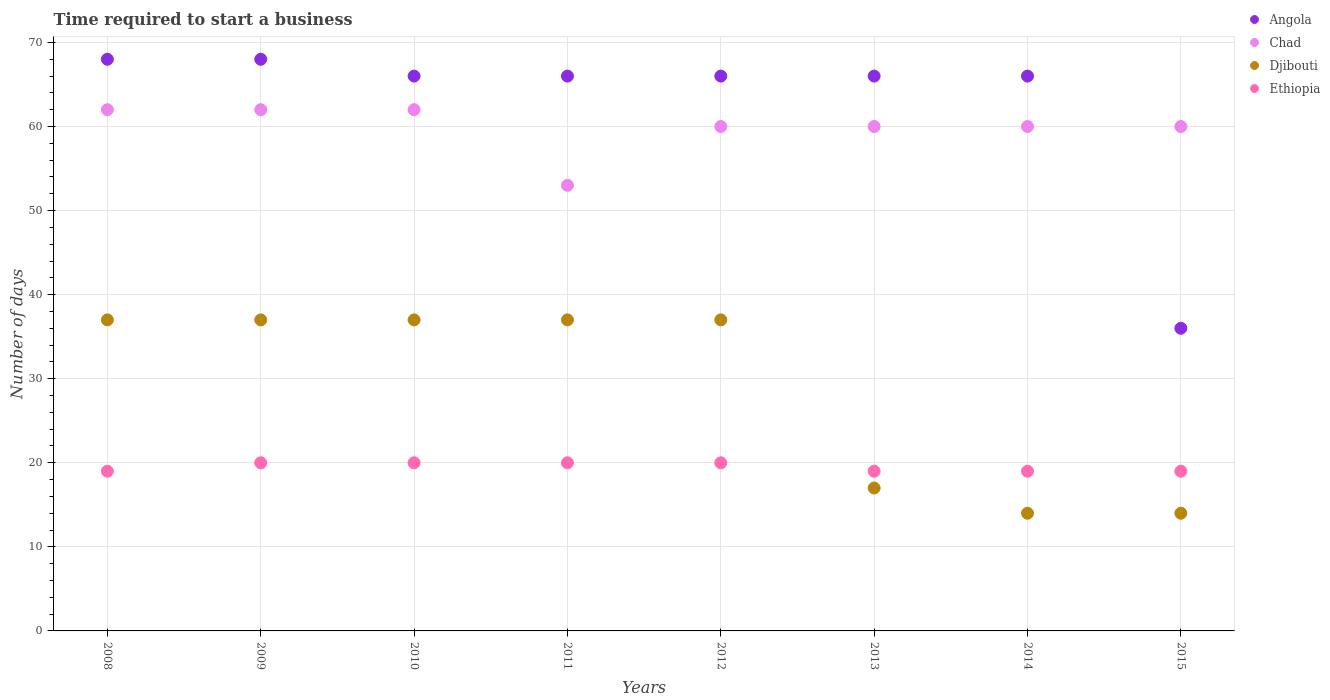Is the number of dotlines equal to the number of legend labels?
Provide a succinct answer. Yes. Across all years, what is the maximum number of days required to start a business in Angola?
Your answer should be very brief. 68. Across all years, what is the minimum number of days required to start a business in Chad?
Offer a very short reply. 53. What is the total number of days required to start a business in Chad in the graph?
Provide a short and direct response. 479. What is the difference between the number of days required to start a business in Chad in 2011 and that in 2015?
Keep it short and to the point. -7. What is the difference between the number of days required to start a business in Ethiopia in 2013 and the number of days required to start a business in Djibouti in 2010?
Ensure brevity in your answer.  -18. What is the average number of days required to start a business in Chad per year?
Keep it short and to the point. 59.88. In the year 2014, what is the difference between the number of days required to start a business in Chad and number of days required to start a business in Ethiopia?
Make the answer very short. 41. In how many years, is the number of days required to start a business in Angola greater than 58 days?
Provide a short and direct response. 7. Is the difference between the number of days required to start a business in Chad in 2009 and 2012 greater than the difference between the number of days required to start a business in Ethiopia in 2009 and 2012?
Your answer should be very brief. Yes. What is the difference between the highest and the lowest number of days required to start a business in Djibouti?
Provide a succinct answer. 23. Is the sum of the number of days required to start a business in Djibouti in 2010 and 2013 greater than the maximum number of days required to start a business in Angola across all years?
Give a very brief answer. No. Is it the case that in every year, the sum of the number of days required to start a business in Angola and number of days required to start a business in Djibouti  is greater than the sum of number of days required to start a business in Chad and number of days required to start a business in Ethiopia?
Make the answer very short. Yes. Is the number of days required to start a business in Ethiopia strictly greater than the number of days required to start a business in Chad over the years?
Ensure brevity in your answer.  No. Is the number of days required to start a business in Ethiopia strictly less than the number of days required to start a business in Angola over the years?
Your response must be concise. Yes. Does the graph contain any zero values?
Ensure brevity in your answer.  No. How many legend labels are there?
Your response must be concise. 4. What is the title of the graph?
Ensure brevity in your answer.  Time required to start a business. Does "South Africa" appear as one of the legend labels in the graph?
Make the answer very short. No. What is the label or title of the X-axis?
Your answer should be very brief. Years. What is the label or title of the Y-axis?
Provide a succinct answer. Number of days. What is the Number of days in Chad in 2008?
Provide a succinct answer. 62. What is the Number of days in Djibouti in 2008?
Your response must be concise. 37. What is the Number of days of Angola in 2009?
Make the answer very short. 68. What is the Number of days of Chad in 2009?
Give a very brief answer. 62. What is the Number of days of Djibouti in 2009?
Your answer should be compact. 37. What is the Number of days of Ethiopia in 2009?
Your answer should be very brief. 20. What is the Number of days of Angola in 2010?
Your answer should be compact. 66. What is the Number of days in Djibouti in 2010?
Offer a very short reply. 37. What is the Number of days in Ethiopia in 2010?
Ensure brevity in your answer.  20. What is the Number of days in Angola in 2011?
Your answer should be compact. 66. What is the Number of days in Chad in 2011?
Keep it short and to the point. 53. What is the Number of days of Djibouti in 2011?
Offer a terse response. 37. What is the Number of days of Angola in 2012?
Provide a short and direct response. 66. What is the Number of days in Chad in 2012?
Make the answer very short. 60. What is the Number of days in Djibouti in 2012?
Provide a short and direct response. 37. What is the Number of days in Ethiopia in 2012?
Your answer should be very brief. 20. What is the Number of days in Angola in 2013?
Ensure brevity in your answer.  66. What is the Number of days in Chad in 2013?
Provide a short and direct response. 60. What is the Number of days in Djibouti in 2013?
Your response must be concise. 17. What is the Number of days of Ethiopia in 2013?
Keep it short and to the point. 19. What is the Number of days in Djibouti in 2014?
Give a very brief answer. 14. What is the Number of days of Chad in 2015?
Give a very brief answer. 60. What is the Number of days of Djibouti in 2015?
Your answer should be very brief. 14. Across all years, what is the maximum Number of days of Chad?
Your answer should be very brief. 62. Across all years, what is the maximum Number of days in Ethiopia?
Provide a short and direct response. 20. Across all years, what is the minimum Number of days of Angola?
Your answer should be compact. 36. What is the total Number of days in Angola in the graph?
Your answer should be compact. 502. What is the total Number of days of Chad in the graph?
Keep it short and to the point. 479. What is the total Number of days of Djibouti in the graph?
Your answer should be very brief. 230. What is the total Number of days of Ethiopia in the graph?
Ensure brevity in your answer.  156. What is the difference between the Number of days of Angola in 2008 and that in 2010?
Your answer should be very brief. 2. What is the difference between the Number of days in Chad in 2008 and that in 2010?
Provide a short and direct response. 0. What is the difference between the Number of days of Ethiopia in 2008 and that in 2010?
Keep it short and to the point. -1. What is the difference between the Number of days in Angola in 2008 and that in 2011?
Keep it short and to the point. 2. What is the difference between the Number of days in Angola in 2008 and that in 2012?
Your response must be concise. 2. What is the difference between the Number of days in Djibouti in 2008 and that in 2012?
Offer a terse response. 0. What is the difference between the Number of days of Ethiopia in 2008 and that in 2012?
Provide a short and direct response. -1. What is the difference between the Number of days in Angola in 2008 and that in 2013?
Make the answer very short. 2. What is the difference between the Number of days of Chad in 2008 and that in 2013?
Your answer should be compact. 2. What is the difference between the Number of days in Ethiopia in 2008 and that in 2013?
Make the answer very short. 0. What is the difference between the Number of days of Ethiopia in 2008 and that in 2015?
Provide a succinct answer. 0. What is the difference between the Number of days in Angola in 2009 and that in 2010?
Ensure brevity in your answer.  2. What is the difference between the Number of days in Djibouti in 2009 and that in 2010?
Your response must be concise. 0. What is the difference between the Number of days in Angola in 2009 and that in 2011?
Keep it short and to the point. 2. What is the difference between the Number of days of Chad in 2009 and that in 2011?
Keep it short and to the point. 9. What is the difference between the Number of days of Djibouti in 2009 and that in 2011?
Keep it short and to the point. 0. What is the difference between the Number of days of Angola in 2009 and that in 2012?
Provide a short and direct response. 2. What is the difference between the Number of days in Ethiopia in 2009 and that in 2012?
Ensure brevity in your answer.  0. What is the difference between the Number of days in Angola in 2009 and that in 2013?
Your answer should be compact. 2. What is the difference between the Number of days in Djibouti in 2009 and that in 2013?
Ensure brevity in your answer.  20. What is the difference between the Number of days of Ethiopia in 2009 and that in 2013?
Your answer should be very brief. 1. What is the difference between the Number of days in Angola in 2009 and that in 2014?
Offer a very short reply. 2. What is the difference between the Number of days of Chad in 2009 and that in 2014?
Provide a succinct answer. 2. What is the difference between the Number of days of Djibouti in 2009 and that in 2014?
Ensure brevity in your answer.  23. What is the difference between the Number of days in Angola in 2009 and that in 2015?
Your answer should be compact. 32. What is the difference between the Number of days of Chad in 2009 and that in 2015?
Keep it short and to the point. 2. What is the difference between the Number of days in Ethiopia in 2009 and that in 2015?
Your answer should be compact. 1. What is the difference between the Number of days of Ethiopia in 2010 and that in 2011?
Offer a very short reply. 0. What is the difference between the Number of days in Djibouti in 2010 and that in 2013?
Give a very brief answer. 20. What is the difference between the Number of days in Ethiopia in 2010 and that in 2013?
Ensure brevity in your answer.  1. What is the difference between the Number of days in Chad in 2010 and that in 2014?
Keep it short and to the point. 2. What is the difference between the Number of days in Djibouti in 2010 and that in 2014?
Offer a terse response. 23. What is the difference between the Number of days in Angola in 2010 and that in 2015?
Make the answer very short. 30. What is the difference between the Number of days of Chad in 2010 and that in 2015?
Your answer should be compact. 2. What is the difference between the Number of days in Djibouti in 2010 and that in 2015?
Make the answer very short. 23. What is the difference between the Number of days in Angola in 2011 and that in 2012?
Offer a terse response. 0. What is the difference between the Number of days in Chad in 2011 and that in 2012?
Your answer should be very brief. -7. What is the difference between the Number of days in Djibouti in 2011 and that in 2012?
Give a very brief answer. 0. What is the difference between the Number of days in Chad in 2011 and that in 2013?
Provide a succinct answer. -7. What is the difference between the Number of days of Djibouti in 2011 and that in 2013?
Provide a short and direct response. 20. What is the difference between the Number of days in Ethiopia in 2011 and that in 2013?
Your answer should be compact. 1. What is the difference between the Number of days in Chad in 2011 and that in 2014?
Offer a very short reply. -7. What is the difference between the Number of days in Djibouti in 2011 and that in 2014?
Your response must be concise. 23. What is the difference between the Number of days of Ethiopia in 2011 and that in 2014?
Provide a succinct answer. 1. What is the difference between the Number of days of Angola in 2011 and that in 2015?
Your response must be concise. 30. What is the difference between the Number of days of Angola in 2012 and that in 2013?
Give a very brief answer. 0. What is the difference between the Number of days in Djibouti in 2012 and that in 2013?
Your answer should be very brief. 20. What is the difference between the Number of days of Ethiopia in 2012 and that in 2013?
Your response must be concise. 1. What is the difference between the Number of days of Chad in 2012 and that in 2014?
Your answer should be very brief. 0. What is the difference between the Number of days of Djibouti in 2012 and that in 2014?
Offer a terse response. 23. What is the difference between the Number of days in Ethiopia in 2012 and that in 2014?
Keep it short and to the point. 1. What is the difference between the Number of days in Angola in 2012 and that in 2015?
Offer a terse response. 30. What is the difference between the Number of days in Ethiopia in 2012 and that in 2015?
Give a very brief answer. 1. What is the difference between the Number of days in Chad in 2013 and that in 2014?
Provide a succinct answer. 0. What is the difference between the Number of days in Ethiopia in 2013 and that in 2014?
Provide a short and direct response. 0. What is the difference between the Number of days in Angola in 2013 and that in 2015?
Keep it short and to the point. 30. What is the difference between the Number of days of Djibouti in 2013 and that in 2015?
Provide a short and direct response. 3. What is the difference between the Number of days in Angola in 2014 and that in 2015?
Ensure brevity in your answer.  30. What is the difference between the Number of days in Angola in 2008 and the Number of days in Chad in 2009?
Your answer should be very brief. 6. What is the difference between the Number of days of Chad in 2008 and the Number of days of Djibouti in 2009?
Keep it short and to the point. 25. What is the difference between the Number of days of Chad in 2008 and the Number of days of Ethiopia in 2009?
Provide a succinct answer. 42. What is the difference between the Number of days in Angola in 2008 and the Number of days in Chad in 2010?
Ensure brevity in your answer.  6. What is the difference between the Number of days in Angola in 2008 and the Number of days in Djibouti in 2010?
Keep it short and to the point. 31. What is the difference between the Number of days of Chad in 2008 and the Number of days of Djibouti in 2010?
Keep it short and to the point. 25. What is the difference between the Number of days of Djibouti in 2008 and the Number of days of Ethiopia in 2010?
Provide a succinct answer. 17. What is the difference between the Number of days in Chad in 2008 and the Number of days in Djibouti in 2011?
Provide a short and direct response. 25. What is the difference between the Number of days in Angola in 2008 and the Number of days in Chad in 2012?
Keep it short and to the point. 8. What is the difference between the Number of days in Angola in 2008 and the Number of days in Djibouti in 2012?
Your answer should be compact. 31. What is the difference between the Number of days of Angola in 2008 and the Number of days of Ethiopia in 2012?
Give a very brief answer. 48. What is the difference between the Number of days of Chad in 2008 and the Number of days of Djibouti in 2012?
Offer a very short reply. 25. What is the difference between the Number of days of Djibouti in 2008 and the Number of days of Ethiopia in 2012?
Your response must be concise. 17. What is the difference between the Number of days in Chad in 2008 and the Number of days in Djibouti in 2013?
Your answer should be very brief. 45. What is the difference between the Number of days of Chad in 2008 and the Number of days of Ethiopia in 2013?
Ensure brevity in your answer.  43. What is the difference between the Number of days of Angola in 2008 and the Number of days of Chad in 2014?
Offer a terse response. 8. What is the difference between the Number of days in Angola in 2008 and the Number of days in Djibouti in 2014?
Your answer should be compact. 54. What is the difference between the Number of days of Angola in 2008 and the Number of days of Ethiopia in 2014?
Your answer should be very brief. 49. What is the difference between the Number of days in Chad in 2008 and the Number of days in Djibouti in 2014?
Provide a succinct answer. 48. What is the difference between the Number of days in Chad in 2008 and the Number of days in Ethiopia in 2014?
Give a very brief answer. 43. What is the difference between the Number of days in Angola in 2008 and the Number of days in Djibouti in 2015?
Give a very brief answer. 54. What is the difference between the Number of days of Angola in 2008 and the Number of days of Ethiopia in 2015?
Offer a terse response. 49. What is the difference between the Number of days in Chad in 2008 and the Number of days in Djibouti in 2015?
Make the answer very short. 48. What is the difference between the Number of days of Djibouti in 2008 and the Number of days of Ethiopia in 2015?
Your answer should be very brief. 18. What is the difference between the Number of days of Angola in 2009 and the Number of days of Ethiopia in 2010?
Make the answer very short. 48. What is the difference between the Number of days of Chad in 2009 and the Number of days of Djibouti in 2010?
Offer a very short reply. 25. What is the difference between the Number of days of Chad in 2009 and the Number of days of Ethiopia in 2010?
Offer a terse response. 42. What is the difference between the Number of days in Djibouti in 2009 and the Number of days in Ethiopia in 2010?
Make the answer very short. 17. What is the difference between the Number of days of Angola in 2009 and the Number of days of Djibouti in 2011?
Your answer should be compact. 31. What is the difference between the Number of days in Chad in 2009 and the Number of days in Djibouti in 2011?
Your answer should be very brief. 25. What is the difference between the Number of days in Djibouti in 2009 and the Number of days in Ethiopia in 2011?
Give a very brief answer. 17. What is the difference between the Number of days in Angola in 2009 and the Number of days in Djibouti in 2012?
Make the answer very short. 31. What is the difference between the Number of days in Chad in 2009 and the Number of days in Djibouti in 2012?
Give a very brief answer. 25. What is the difference between the Number of days in Chad in 2009 and the Number of days in Djibouti in 2013?
Make the answer very short. 45. What is the difference between the Number of days in Djibouti in 2009 and the Number of days in Ethiopia in 2013?
Your answer should be very brief. 18. What is the difference between the Number of days of Angola in 2009 and the Number of days of Chad in 2014?
Keep it short and to the point. 8. What is the difference between the Number of days in Angola in 2009 and the Number of days in Ethiopia in 2014?
Give a very brief answer. 49. What is the difference between the Number of days in Chad in 2009 and the Number of days in Djibouti in 2014?
Your response must be concise. 48. What is the difference between the Number of days in Chad in 2009 and the Number of days in Ethiopia in 2014?
Offer a very short reply. 43. What is the difference between the Number of days in Djibouti in 2009 and the Number of days in Ethiopia in 2014?
Your answer should be compact. 18. What is the difference between the Number of days of Angola in 2009 and the Number of days of Chad in 2015?
Your answer should be compact. 8. What is the difference between the Number of days of Angola in 2009 and the Number of days of Ethiopia in 2015?
Your answer should be very brief. 49. What is the difference between the Number of days of Chad in 2009 and the Number of days of Djibouti in 2015?
Offer a terse response. 48. What is the difference between the Number of days in Chad in 2009 and the Number of days in Ethiopia in 2015?
Your answer should be compact. 43. What is the difference between the Number of days in Djibouti in 2009 and the Number of days in Ethiopia in 2015?
Your answer should be compact. 18. What is the difference between the Number of days of Angola in 2010 and the Number of days of Djibouti in 2011?
Offer a terse response. 29. What is the difference between the Number of days in Angola in 2010 and the Number of days in Ethiopia in 2011?
Give a very brief answer. 46. What is the difference between the Number of days in Djibouti in 2010 and the Number of days in Ethiopia in 2011?
Your answer should be compact. 17. What is the difference between the Number of days of Chad in 2010 and the Number of days of Ethiopia in 2012?
Your answer should be very brief. 42. What is the difference between the Number of days of Djibouti in 2010 and the Number of days of Ethiopia in 2012?
Offer a very short reply. 17. What is the difference between the Number of days of Angola in 2010 and the Number of days of Djibouti in 2013?
Keep it short and to the point. 49. What is the difference between the Number of days of Chad in 2010 and the Number of days of Djibouti in 2013?
Offer a terse response. 45. What is the difference between the Number of days in Chad in 2010 and the Number of days in Ethiopia in 2013?
Ensure brevity in your answer.  43. What is the difference between the Number of days in Djibouti in 2010 and the Number of days in Ethiopia in 2013?
Ensure brevity in your answer.  18. What is the difference between the Number of days in Angola in 2010 and the Number of days in Chad in 2014?
Your answer should be very brief. 6. What is the difference between the Number of days of Angola in 2010 and the Number of days of Djibouti in 2014?
Your response must be concise. 52. What is the difference between the Number of days of Angola in 2010 and the Number of days of Ethiopia in 2014?
Ensure brevity in your answer.  47. What is the difference between the Number of days in Chad in 2010 and the Number of days in Djibouti in 2014?
Provide a succinct answer. 48. What is the difference between the Number of days of Angola in 2010 and the Number of days of Djibouti in 2015?
Your response must be concise. 52. What is the difference between the Number of days of Chad in 2010 and the Number of days of Djibouti in 2015?
Offer a terse response. 48. What is the difference between the Number of days in Chad in 2010 and the Number of days in Ethiopia in 2015?
Offer a terse response. 43. What is the difference between the Number of days of Angola in 2011 and the Number of days of Chad in 2012?
Your answer should be very brief. 6. What is the difference between the Number of days of Angola in 2011 and the Number of days of Djibouti in 2012?
Make the answer very short. 29. What is the difference between the Number of days in Angola in 2011 and the Number of days in Ethiopia in 2012?
Make the answer very short. 46. What is the difference between the Number of days in Chad in 2011 and the Number of days in Ethiopia in 2012?
Provide a succinct answer. 33. What is the difference between the Number of days in Angola in 2011 and the Number of days in Ethiopia in 2013?
Your answer should be compact. 47. What is the difference between the Number of days of Chad in 2011 and the Number of days of Djibouti in 2013?
Offer a very short reply. 36. What is the difference between the Number of days in Djibouti in 2011 and the Number of days in Ethiopia in 2013?
Keep it short and to the point. 18. What is the difference between the Number of days of Angola in 2011 and the Number of days of Ethiopia in 2014?
Offer a very short reply. 47. What is the difference between the Number of days of Chad in 2011 and the Number of days of Djibouti in 2014?
Ensure brevity in your answer.  39. What is the difference between the Number of days in Chad in 2011 and the Number of days in Ethiopia in 2014?
Keep it short and to the point. 34. What is the difference between the Number of days of Djibouti in 2011 and the Number of days of Ethiopia in 2014?
Give a very brief answer. 18. What is the difference between the Number of days of Angola in 2011 and the Number of days of Djibouti in 2015?
Your response must be concise. 52. What is the difference between the Number of days of Chad in 2011 and the Number of days of Ethiopia in 2015?
Your response must be concise. 34. What is the difference between the Number of days of Djibouti in 2011 and the Number of days of Ethiopia in 2015?
Provide a short and direct response. 18. What is the difference between the Number of days in Angola in 2012 and the Number of days in Djibouti in 2013?
Give a very brief answer. 49. What is the difference between the Number of days in Angola in 2012 and the Number of days in Ethiopia in 2013?
Your answer should be compact. 47. What is the difference between the Number of days of Chad in 2012 and the Number of days of Ethiopia in 2013?
Provide a succinct answer. 41. What is the difference between the Number of days in Djibouti in 2012 and the Number of days in Ethiopia in 2013?
Offer a terse response. 18. What is the difference between the Number of days in Angola in 2012 and the Number of days in Djibouti in 2014?
Ensure brevity in your answer.  52. What is the difference between the Number of days in Angola in 2012 and the Number of days in Ethiopia in 2014?
Keep it short and to the point. 47. What is the difference between the Number of days of Chad in 2012 and the Number of days of Ethiopia in 2014?
Give a very brief answer. 41. What is the difference between the Number of days of Djibouti in 2012 and the Number of days of Ethiopia in 2014?
Your answer should be very brief. 18. What is the difference between the Number of days of Angola in 2012 and the Number of days of Ethiopia in 2015?
Make the answer very short. 47. What is the difference between the Number of days of Chad in 2012 and the Number of days of Ethiopia in 2015?
Make the answer very short. 41. What is the difference between the Number of days in Djibouti in 2012 and the Number of days in Ethiopia in 2015?
Provide a succinct answer. 18. What is the difference between the Number of days of Angola in 2013 and the Number of days of Chad in 2014?
Provide a succinct answer. 6. What is the difference between the Number of days in Chad in 2013 and the Number of days in Ethiopia in 2014?
Offer a very short reply. 41. What is the difference between the Number of days in Djibouti in 2013 and the Number of days in Ethiopia in 2014?
Your answer should be very brief. -2. What is the difference between the Number of days of Angola in 2013 and the Number of days of Chad in 2015?
Your answer should be compact. 6. What is the difference between the Number of days of Angola in 2013 and the Number of days of Djibouti in 2015?
Provide a succinct answer. 52. What is the difference between the Number of days of Chad in 2013 and the Number of days of Djibouti in 2015?
Offer a very short reply. 46. What is the difference between the Number of days in Chad in 2013 and the Number of days in Ethiopia in 2015?
Ensure brevity in your answer.  41. What is the average Number of days in Angola per year?
Your answer should be very brief. 62.75. What is the average Number of days of Chad per year?
Offer a terse response. 59.88. What is the average Number of days of Djibouti per year?
Your response must be concise. 28.75. In the year 2008, what is the difference between the Number of days in Angola and Number of days in Ethiopia?
Your response must be concise. 49. In the year 2008, what is the difference between the Number of days in Chad and Number of days in Djibouti?
Your answer should be very brief. 25. In the year 2008, what is the difference between the Number of days of Chad and Number of days of Ethiopia?
Your answer should be compact. 43. In the year 2009, what is the difference between the Number of days in Angola and Number of days in Chad?
Provide a succinct answer. 6. In the year 2009, what is the difference between the Number of days of Angola and Number of days of Djibouti?
Your answer should be very brief. 31. In the year 2009, what is the difference between the Number of days of Angola and Number of days of Ethiopia?
Provide a succinct answer. 48. In the year 2009, what is the difference between the Number of days of Chad and Number of days of Djibouti?
Keep it short and to the point. 25. In the year 2010, what is the difference between the Number of days in Angola and Number of days in Ethiopia?
Make the answer very short. 46. In the year 2010, what is the difference between the Number of days in Chad and Number of days in Djibouti?
Ensure brevity in your answer.  25. In the year 2010, what is the difference between the Number of days of Djibouti and Number of days of Ethiopia?
Provide a short and direct response. 17. In the year 2011, what is the difference between the Number of days in Angola and Number of days in Ethiopia?
Give a very brief answer. 46. In the year 2011, what is the difference between the Number of days in Djibouti and Number of days in Ethiopia?
Keep it short and to the point. 17. In the year 2012, what is the difference between the Number of days in Angola and Number of days in Djibouti?
Your answer should be very brief. 29. In the year 2012, what is the difference between the Number of days in Angola and Number of days in Ethiopia?
Offer a terse response. 46. In the year 2012, what is the difference between the Number of days of Chad and Number of days of Ethiopia?
Offer a terse response. 40. In the year 2013, what is the difference between the Number of days in Djibouti and Number of days in Ethiopia?
Give a very brief answer. -2. In the year 2014, what is the difference between the Number of days in Angola and Number of days in Chad?
Provide a succinct answer. 6. In the year 2014, what is the difference between the Number of days in Chad and Number of days in Djibouti?
Keep it short and to the point. 46. In the year 2014, what is the difference between the Number of days of Chad and Number of days of Ethiopia?
Your response must be concise. 41. In the year 2014, what is the difference between the Number of days of Djibouti and Number of days of Ethiopia?
Provide a short and direct response. -5. In the year 2015, what is the difference between the Number of days in Chad and Number of days in Djibouti?
Offer a very short reply. 46. In the year 2015, what is the difference between the Number of days of Chad and Number of days of Ethiopia?
Offer a terse response. 41. In the year 2015, what is the difference between the Number of days of Djibouti and Number of days of Ethiopia?
Offer a terse response. -5. What is the ratio of the Number of days in Djibouti in 2008 to that in 2009?
Give a very brief answer. 1. What is the ratio of the Number of days of Ethiopia in 2008 to that in 2009?
Offer a very short reply. 0.95. What is the ratio of the Number of days in Angola in 2008 to that in 2010?
Offer a very short reply. 1.03. What is the ratio of the Number of days in Djibouti in 2008 to that in 2010?
Make the answer very short. 1. What is the ratio of the Number of days of Ethiopia in 2008 to that in 2010?
Provide a succinct answer. 0.95. What is the ratio of the Number of days of Angola in 2008 to that in 2011?
Your response must be concise. 1.03. What is the ratio of the Number of days in Chad in 2008 to that in 2011?
Provide a succinct answer. 1.17. What is the ratio of the Number of days in Djibouti in 2008 to that in 2011?
Offer a very short reply. 1. What is the ratio of the Number of days of Ethiopia in 2008 to that in 2011?
Make the answer very short. 0.95. What is the ratio of the Number of days of Angola in 2008 to that in 2012?
Provide a succinct answer. 1.03. What is the ratio of the Number of days in Chad in 2008 to that in 2012?
Offer a very short reply. 1.03. What is the ratio of the Number of days in Ethiopia in 2008 to that in 2012?
Give a very brief answer. 0.95. What is the ratio of the Number of days of Angola in 2008 to that in 2013?
Your answer should be very brief. 1.03. What is the ratio of the Number of days of Djibouti in 2008 to that in 2013?
Provide a succinct answer. 2.18. What is the ratio of the Number of days of Ethiopia in 2008 to that in 2013?
Ensure brevity in your answer.  1. What is the ratio of the Number of days of Angola in 2008 to that in 2014?
Ensure brevity in your answer.  1.03. What is the ratio of the Number of days of Chad in 2008 to that in 2014?
Provide a short and direct response. 1.03. What is the ratio of the Number of days in Djibouti in 2008 to that in 2014?
Ensure brevity in your answer.  2.64. What is the ratio of the Number of days of Ethiopia in 2008 to that in 2014?
Make the answer very short. 1. What is the ratio of the Number of days in Angola in 2008 to that in 2015?
Your answer should be very brief. 1.89. What is the ratio of the Number of days in Djibouti in 2008 to that in 2015?
Keep it short and to the point. 2.64. What is the ratio of the Number of days in Angola in 2009 to that in 2010?
Ensure brevity in your answer.  1.03. What is the ratio of the Number of days in Chad in 2009 to that in 2010?
Give a very brief answer. 1. What is the ratio of the Number of days of Angola in 2009 to that in 2011?
Keep it short and to the point. 1.03. What is the ratio of the Number of days of Chad in 2009 to that in 2011?
Offer a very short reply. 1.17. What is the ratio of the Number of days in Ethiopia in 2009 to that in 2011?
Provide a short and direct response. 1. What is the ratio of the Number of days of Angola in 2009 to that in 2012?
Make the answer very short. 1.03. What is the ratio of the Number of days of Chad in 2009 to that in 2012?
Offer a very short reply. 1.03. What is the ratio of the Number of days of Djibouti in 2009 to that in 2012?
Offer a terse response. 1. What is the ratio of the Number of days of Ethiopia in 2009 to that in 2012?
Keep it short and to the point. 1. What is the ratio of the Number of days in Angola in 2009 to that in 2013?
Make the answer very short. 1.03. What is the ratio of the Number of days of Chad in 2009 to that in 2013?
Offer a terse response. 1.03. What is the ratio of the Number of days of Djibouti in 2009 to that in 2013?
Give a very brief answer. 2.18. What is the ratio of the Number of days of Ethiopia in 2009 to that in 2013?
Make the answer very short. 1.05. What is the ratio of the Number of days in Angola in 2009 to that in 2014?
Keep it short and to the point. 1.03. What is the ratio of the Number of days of Djibouti in 2009 to that in 2014?
Offer a terse response. 2.64. What is the ratio of the Number of days of Ethiopia in 2009 to that in 2014?
Provide a short and direct response. 1.05. What is the ratio of the Number of days of Angola in 2009 to that in 2015?
Offer a terse response. 1.89. What is the ratio of the Number of days in Djibouti in 2009 to that in 2015?
Your response must be concise. 2.64. What is the ratio of the Number of days of Ethiopia in 2009 to that in 2015?
Make the answer very short. 1.05. What is the ratio of the Number of days in Chad in 2010 to that in 2011?
Provide a succinct answer. 1.17. What is the ratio of the Number of days of Djibouti in 2010 to that in 2011?
Offer a very short reply. 1. What is the ratio of the Number of days of Ethiopia in 2010 to that in 2011?
Provide a succinct answer. 1. What is the ratio of the Number of days of Djibouti in 2010 to that in 2012?
Provide a succinct answer. 1. What is the ratio of the Number of days in Djibouti in 2010 to that in 2013?
Provide a succinct answer. 2.18. What is the ratio of the Number of days of Ethiopia in 2010 to that in 2013?
Make the answer very short. 1.05. What is the ratio of the Number of days of Chad in 2010 to that in 2014?
Give a very brief answer. 1.03. What is the ratio of the Number of days in Djibouti in 2010 to that in 2014?
Give a very brief answer. 2.64. What is the ratio of the Number of days of Ethiopia in 2010 to that in 2014?
Your answer should be very brief. 1.05. What is the ratio of the Number of days in Angola in 2010 to that in 2015?
Provide a short and direct response. 1.83. What is the ratio of the Number of days in Djibouti in 2010 to that in 2015?
Provide a short and direct response. 2.64. What is the ratio of the Number of days in Ethiopia in 2010 to that in 2015?
Your answer should be very brief. 1.05. What is the ratio of the Number of days in Angola in 2011 to that in 2012?
Your answer should be very brief. 1. What is the ratio of the Number of days in Chad in 2011 to that in 2012?
Make the answer very short. 0.88. What is the ratio of the Number of days in Ethiopia in 2011 to that in 2012?
Your response must be concise. 1. What is the ratio of the Number of days in Angola in 2011 to that in 2013?
Your response must be concise. 1. What is the ratio of the Number of days of Chad in 2011 to that in 2013?
Your response must be concise. 0.88. What is the ratio of the Number of days of Djibouti in 2011 to that in 2013?
Ensure brevity in your answer.  2.18. What is the ratio of the Number of days of Ethiopia in 2011 to that in 2013?
Offer a very short reply. 1.05. What is the ratio of the Number of days of Angola in 2011 to that in 2014?
Give a very brief answer. 1. What is the ratio of the Number of days of Chad in 2011 to that in 2014?
Ensure brevity in your answer.  0.88. What is the ratio of the Number of days in Djibouti in 2011 to that in 2014?
Keep it short and to the point. 2.64. What is the ratio of the Number of days in Ethiopia in 2011 to that in 2014?
Provide a short and direct response. 1.05. What is the ratio of the Number of days in Angola in 2011 to that in 2015?
Offer a terse response. 1.83. What is the ratio of the Number of days of Chad in 2011 to that in 2015?
Make the answer very short. 0.88. What is the ratio of the Number of days of Djibouti in 2011 to that in 2015?
Ensure brevity in your answer.  2.64. What is the ratio of the Number of days of Ethiopia in 2011 to that in 2015?
Make the answer very short. 1.05. What is the ratio of the Number of days of Angola in 2012 to that in 2013?
Make the answer very short. 1. What is the ratio of the Number of days of Djibouti in 2012 to that in 2013?
Give a very brief answer. 2.18. What is the ratio of the Number of days in Ethiopia in 2012 to that in 2013?
Your answer should be compact. 1.05. What is the ratio of the Number of days in Djibouti in 2012 to that in 2014?
Make the answer very short. 2.64. What is the ratio of the Number of days in Ethiopia in 2012 to that in 2014?
Keep it short and to the point. 1.05. What is the ratio of the Number of days in Angola in 2012 to that in 2015?
Your answer should be compact. 1.83. What is the ratio of the Number of days of Djibouti in 2012 to that in 2015?
Your answer should be very brief. 2.64. What is the ratio of the Number of days of Ethiopia in 2012 to that in 2015?
Keep it short and to the point. 1.05. What is the ratio of the Number of days in Angola in 2013 to that in 2014?
Ensure brevity in your answer.  1. What is the ratio of the Number of days of Chad in 2013 to that in 2014?
Make the answer very short. 1. What is the ratio of the Number of days of Djibouti in 2013 to that in 2014?
Offer a terse response. 1.21. What is the ratio of the Number of days of Angola in 2013 to that in 2015?
Offer a terse response. 1.83. What is the ratio of the Number of days of Chad in 2013 to that in 2015?
Offer a terse response. 1. What is the ratio of the Number of days in Djibouti in 2013 to that in 2015?
Ensure brevity in your answer.  1.21. What is the ratio of the Number of days in Angola in 2014 to that in 2015?
Give a very brief answer. 1.83. What is the ratio of the Number of days in Chad in 2014 to that in 2015?
Your response must be concise. 1. What is the difference between the highest and the second highest Number of days in Angola?
Offer a very short reply. 0. What is the difference between the highest and the second highest Number of days in Chad?
Offer a very short reply. 0. What is the difference between the highest and the second highest Number of days of Djibouti?
Keep it short and to the point. 0. What is the difference between the highest and the second highest Number of days in Ethiopia?
Your response must be concise. 0. What is the difference between the highest and the lowest Number of days in Angola?
Provide a short and direct response. 32. 